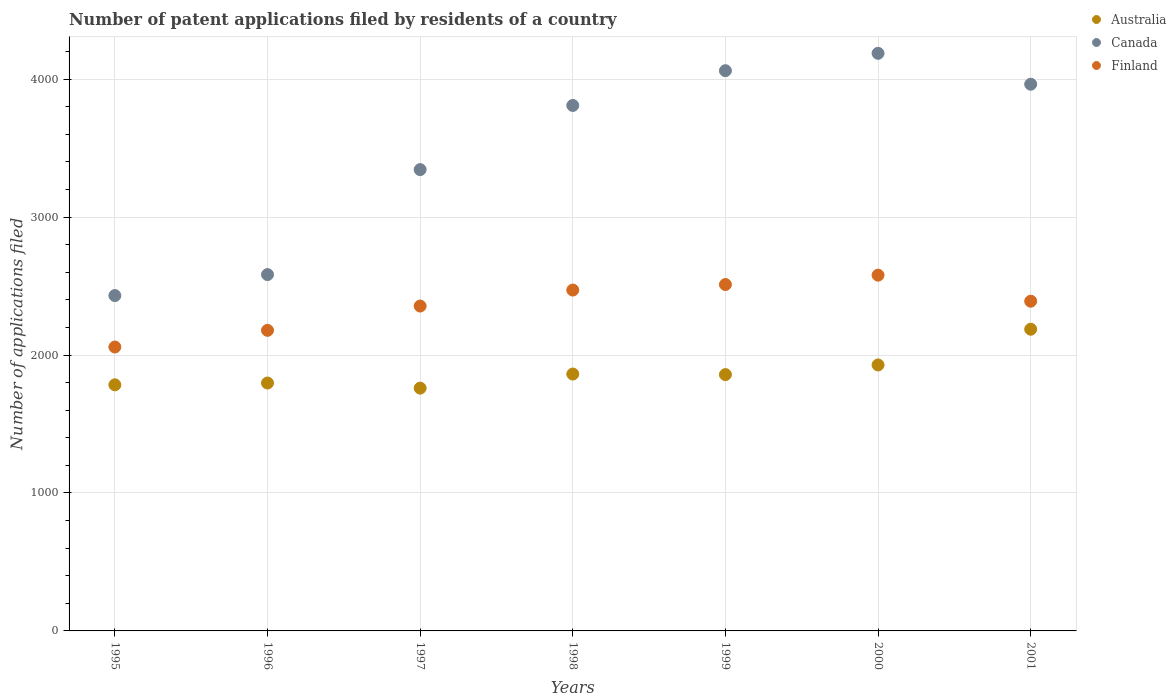How many different coloured dotlines are there?
Provide a succinct answer. 3. What is the number of applications filed in Canada in 1999?
Provide a short and direct response. 4061. Across all years, what is the maximum number of applications filed in Finland?
Provide a short and direct response. 2579. Across all years, what is the minimum number of applications filed in Finland?
Offer a terse response. 2058. What is the total number of applications filed in Australia in the graph?
Your answer should be compact. 1.32e+04. What is the difference between the number of applications filed in Australia in 1996 and that in 1998?
Your answer should be compact. -65. What is the difference between the number of applications filed in Canada in 1998 and the number of applications filed in Finland in 2001?
Offer a very short reply. 1419. What is the average number of applications filed in Canada per year?
Keep it short and to the point. 3482.57. In the year 1996, what is the difference between the number of applications filed in Canada and number of applications filed in Australia?
Your answer should be compact. 786. In how many years, is the number of applications filed in Australia greater than 600?
Provide a short and direct response. 7. What is the ratio of the number of applications filed in Canada in 1998 to that in 2001?
Give a very brief answer. 0.96. Is the number of applications filed in Australia in 1997 less than that in 1999?
Offer a very short reply. Yes. What is the difference between the highest and the second highest number of applications filed in Canada?
Your answer should be very brief. 126. What is the difference between the highest and the lowest number of applications filed in Canada?
Provide a succinct answer. 1756. Is the sum of the number of applications filed in Finland in 1995 and 1999 greater than the maximum number of applications filed in Canada across all years?
Your answer should be compact. Yes. Is it the case that in every year, the sum of the number of applications filed in Finland and number of applications filed in Canada  is greater than the number of applications filed in Australia?
Your answer should be very brief. Yes. Is the number of applications filed in Australia strictly greater than the number of applications filed in Finland over the years?
Your response must be concise. No. Is the number of applications filed in Canada strictly less than the number of applications filed in Finland over the years?
Provide a succinct answer. No. How many dotlines are there?
Ensure brevity in your answer.  3. What is the difference between two consecutive major ticks on the Y-axis?
Provide a succinct answer. 1000. Does the graph contain any zero values?
Give a very brief answer. No. Does the graph contain grids?
Offer a terse response. Yes. How many legend labels are there?
Provide a succinct answer. 3. How are the legend labels stacked?
Your answer should be compact. Vertical. What is the title of the graph?
Give a very brief answer. Number of patent applications filed by residents of a country. What is the label or title of the X-axis?
Make the answer very short. Years. What is the label or title of the Y-axis?
Offer a terse response. Number of applications filed. What is the Number of applications filed of Australia in 1995?
Your answer should be very brief. 1784. What is the Number of applications filed of Canada in 1995?
Give a very brief answer. 2431. What is the Number of applications filed of Finland in 1995?
Your response must be concise. 2058. What is the Number of applications filed in Australia in 1996?
Keep it short and to the point. 1797. What is the Number of applications filed of Canada in 1996?
Your answer should be compact. 2583. What is the Number of applications filed of Finland in 1996?
Keep it short and to the point. 2179. What is the Number of applications filed of Australia in 1997?
Keep it short and to the point. 1760. What is the Number of applications filed in Canada in 1997?
Provide a short and direct response. 3344. What is the Number of applications filed of Finland in 1997?
Ensure brevity in your answer.  2355. What is the Number of applications filed in Australia in 1998?
Provide a succinct answer. 1862. What is the Number of applications filed of Canada in 1998?
Provide a short and direct response. 3809. What is the Number of applications filed in Finland in 1998?
Ensure brevity in your answer.  2471. What is the Number of applications filed in Australia in 1999?
Your answer should be very brief. 1858. What is the Number of applications filed of Canada in 1999?
Offer a terse response. 4061. What is the Number of applications filed of Finland in 1999?
Offer a very short reply. 2511. What is the Number of applications filed of Australia in 2000?
Provide a short and direct response. 1928. What is the Number of applications filed of Canada in 2000?
Offer a very short reply. 4187. What is the Number of applications filed of Finland in 2000?
Your answer should be very brief. 2579. What is the Number of applications filed of Australia in 2001?
Provide a succinct answer. 2187. What is the Number of applications filed of Canada in 2001?
Offer a terse response. 3963. What is the Number of applications filed of Finland in 2001?
Make the answer very short. 2390. Across all years, what is the maximum Number of applications filed of Australia?
Your answer should be very brief. 2187. Across all years, what is the maximum Number of applications filed of Canada?
Your answer should be compact. 4187. Across all years, what is the maximum Number of applications filed in Finland?
Your answer should be compact. 2579. Across all years, what is the minimum Number of applications filed of Australia?
Your response must be concise. 1760. Across all years, what is the minimum Number of applications filed in Canada?
Make the answer very short. 2431. Across all years, what is the minimum Number of applications filed of Finland?
Give a very brief answer. 2058. What is the total Number of applications filed in Australia in the graph?
Your response must be concise. 1.32e+04. What is the total Number of applications filed of Canada in the graph?
Keep it short and to the point. 2.44e+04. What is the total Number of applications filed in Finland in the graph?
Provide a short and direct response. 1.65e+04. What is the difference between the Number of applications filed in Canada in 1995 and that in 1996?
Provide a succinct answer. -152. What is the difference between the Number of applications filed of Finland in 1995 and that in 1996?
Your answer should be very brief. -121. What is the difference between the Number of applications filed in Australia in 1995 and that in 1997?
Ensure brevity in your answer.  24. What is the difference between the Number of applications filed in Canada in 1995 and that in 1997?
Provide a succinct answer. -913. What is the difference between the Number of applications filed in Finland in 1995 and that in 1997?
Your answer should be compact. -297. What is the difference between the Number of applications filed in Australia in 1995 and that in 1998?
Your response must be concise. -78. What is the difference between the Number of applications filed of Canada in 1995 and that in 1998?
Provide a succinct answer. -1378. What is the difference between the Number of applications filed in Finland in 1995 and that in 1998?
Offer a very short reply. -413. What is the difference between the Number of applications filed of Australia in 1995 and that in 1999?
Provide a short and direct response. -74. What is the difference between the Number of applications filed in Canada in 1995 and that in 1999?
Provide a succinct answer. -1630. What is the difference between the Number of applications filed of Finland in 1995 and that in 1999?
Your answer should be very brief. -453. What is the difference between the Number of applications filed of Australia in 1995 and that in 2000?
Give a very brief answer. -144. What is the difference between the Number of applications filed in Canada in 1995 and that in 2000?
Provide a short and direct response. -1756. What is the difference between the Number of applications filed in Finland in 1995 and that in 2000?
Give a very brief answer. -521. What is the difference between the Number of applications filed in Australia in 1995 and that in 2001?
Make the answer very short. -403. What is the difference between the Number of applications filed of Canada in 1995 and that in 2001?
Give a very brief answer. -1532. What is the difference between the Number of applications filed in Finland in 1995 and that in 2001?
Make the answer very short. -332. What is the difference between the Number of applications filed of Australia in 1996 and that in 1997?
Offer a very short reply. 37. What is the difference between the Number of applications filed of Canada in 1996 and that in 1997?
Offer a terse response. -761. What is the difference between the Number of applications filed of Finland in 1996 and that in 1997?
Your response must be concise. -176. What is the difference between the Number of applications filed of Australia in 1996 and that in 1998?
Offer a very short reply. -65. What is the difference between the Number of applications filed in Canada in 1996 and that in 1998?
Offer a terse response. -1226. What is the difference between the Number of applications filed of Finland in 1996 and that in 1998?
Your answer should be compact. -292. What is the difference between the Number of applications filed of Australia in 1996 and that in 1999?
Offer a terse response. -61. What is the difference between the Number of applications filed in Canada in 1996 and that in 1999?
Your answer should be compact. -1478. What is the difference between the Number of applications filed of Finland in 1996 and that in 1999?
Offer a very short reply. -332. What is the difference between the Number of applications filed in Australia in 1996 and that in 2000?
Offer a terse response. -131. What is the difference between the Number of applications filed of Canada in 1996 and that in 2000?
Provide a succinct answer. -1604. What is the difference between the Number of applications filed of Finland in 1996 and that in 2000?
Provide a short and direct response. -400. What is the difference between the Number of applications filed in Australia in 1996 and that in 2001?
Provide a short and direct response. -390. What is the difference between the Number of applications filed in Canada in 1996 and that in 2001?
Make the answer very short. -1380. What is the difference between the Number of applications filed in Finland in 1996 and that in 2001?
Make the answer very short. -211. What is the difference between the Number of applications filed in Australia in 1997 and that in 1998?
Provide a succinct answer. -102. What is the difference between the Number of applications filed in Canada in 1997 and that in 1998?
Give a very brief answer. -465. What is the difference between the Number of applications filed of Finland in 1997 and that in 1998?
Your answer should be very brief. -116. What is the difference between the Number of applications filed of Australia in 1997 and that in 1999?
Offer a terse response. -98. What is the difference between the Number of applications filed in Canada in 1997 and that in 1999?
Your answer should be very brief. -717. What is the difference between the Number of applications filed of Finland in 1997 and that in 1999?
Your answer should be very brief. -156. What is the difference between the Number of applications filed in Australia in 1997 and that in 2000?
Offer a terse response. -168. What is the difference between the Number of applications filed in Canada in 1997 and that in 2000?
Provide a succinct answer. -843. What is the difference between the Number of applications filed in Finland in 1997 and that in 2000?
Make the answer very short. -224. What is the difference between the Number of applications filed in Australia in 1997 and that in 2001?
Your answer should be compact. -427. What is the difference between the Number of applications filed of Canada in 1997 and that in 2001?
Your response must be concise. -619. What is the difference between the Number of applications filed of Finland in 1997 and that in 2001?
Your answer should be very brief. -35. What is the difference between the Number of applications filed of Canada in 1998 and that in 1999?
Keep it short and to the point. -252. What is the difference between the Number of applications filed of Australia in 1998 and that in 2000?
Provide a succinct answer. -66. What is the difference between the Number of applications filed of Canada in 1998 and that in 2000?
Provide a short and direct response. -378. What is the difference between the Number of applications filed in Finland in 1998 and that in 2000?
Give a very brief answer. -108. What is the difference between the Number of applications filed in Australia in 1998 and that in 2001?
Give a very brief answer. -325. What is the difference between the Number of applications filed in Canada in 1998 and that in 2001?
Your answer should be compact. -154. What is the difference between the Number of applications filed in Australia in 1999 and that in 2000?
Give a very brief answer. -70. What is the difference between the Number of applications filed in Canada in 1999 and that in 2000?
Your response must be concise. -126. What is the difference between the Number of applications filed of Finland in 1999 and that in 2000?
Ensure brevity in your answer.  -68. What is the difference between the Number of applications filed of Australia in 1999 and that in 2001?
Offer a very short reply. -329. What is the difference between the Number of applications filed in Canada in 1999 and that in 2001?
Your answer should be very brief. 98. What is the difference between the Number of applications filed of Finland in 1999 and that in 2001?
Offer a very short reply. 121. What is the difference between the Number of applications filed in Australia in 2000 and that in 2001?
Offer a terse response. -259. What is the difference between the Number of applications filed in Canada in 2000 and that in 2001?
Keep it short and to the point. 224. What is the difference between the Number of applications filed in Finland in 2000 and that in 2001?
Ensure brevity in your answer.  189. What is the difference between the Number of applications filed of Australia in 1995 and the Number of applications filed of Canada in 1996?
Ensure brevity in your answer.  -799. What is the difference between the Number of applications filed in Australia in 1995 and the Number of applications filed in Finland in 1996?
Provide a succinct answer. -395. What is the difference between the Number of applications filed in Canada in 1995 and the Number of applications filed in Finland in 1996?
Provide a short and direct response. 252. What is the difference between the Number of applications filed of Australia in 1995 and the Number of applications filed of Canada in 1997?
Provide a succinct answer. -1560. What is the difference between the Number of applications filed of Australia in 1995 and the Number of applications filed of Finland in 1997?
Provide a succinct answer. -571. What is the difference between the Number of applications filed in Australia in 1995 and the Number of applications filed in Canada in 1998?
Provide a short and direct response. -2025. What is the difference between the Number of applications filed of Australia in 1995 and the Number of applications filed of Finland in 1998?
Your answer should be very brief. -687. What is the difference between the Number of applications filed of Canada in 1995 and the Number of applications filed of Finland in 1998?
Your response must be concise. -40. What is the difference between the Number of applications filed of Australia in 1995 and the Number of applications filed of Canada in 1999?
Your response must be concise. -2277. What is the difference between the Number of applications filed in Australia in 1995 and the Number of applications filed in Finland in 1999?
Make the answer very short. -727. What is the difference between the Number of applications filed in Canada in 1995 and the Number of applications filed in Finland in 1999?
Your response must be concise. -80. What is the difference between the Number of applications filed in Australia in 1995 and the Number of applications filed in Canada in 2000?
Give a very brief answer. -2403. What is the difference between the Number of applications filed in Australia in 1995 and the Number of applications filed in Finland in 2000?
Your response must be concise. -795. What is the difference between the Number of applications filed of Canada in 1995 and the Number of applications filed of Finland in 2000?
Offer a very short reply. -148. What is the difference between the Number of applications filed of Australia in 1995 and the Number of applications filed of Canada in 2001?
Ensure brevity in your answer.  -2179. What is the difference between the Number of applications filed of Australia in 1995 and the Number of applications filed of Finland in 2001?
Provide a short and direct response. -606. What is the difference between the Number of applications filed in Canada in 1995 and the Number of applications filed in Finland in 2001?
Provide a succinct answer. 41. What is the difference between the Number of applications filed of Australia in 1996 and the Number of applications filed of Canada in 1997?
Offer a terse response. -1547. What is the difference between the Number of applications filed in Australia in 1996 and the Number of applications filed in Finland in 1997?
Provide a succinct answer. -558. What is the difference between the Number of applications filed of Canada in 1996 and the Number of applications filed of Finland in 1997?
Your response must be concise. 228. What is the difference between the Number of applications filed in Australia in 1996 and the Number of applications filed in Canada in 1998?
Give a very brief answer. -2012. What is the difference between the Number of applications filed of Australia in 1996 and the Number of applications filed of Finland in 1998?
Your answer should be compact. -674. What is the difference between the Number of applications filed in Canada in 1996 and the Number of applications filed in Finland in 1998?
Offer a terse response. 112. What is the difference between the Number of applications filed of Australia in 1996 and the Number of applications filed of Canada in 1999?
Ensure brevity in your answer.  -2264. What is the difference between the Number of applications filed in Australia in 1996 and the Number of applications filed in Finland in 1999?
Give a very brief answer. -714. What is the difference between the Number of applications filed in Australia in 1996 and the Number of applications filed in Canada in 2000?
Your answer should be compact. -2390. What is the difference between the Number of applications filed in Australia in 1996 and the Number of applications filed in Finland in 2000?
Make the answer very short. -782. What is the difference between the Number of applications filed of Canada in 1996 and the Number of applications filed of Finland in 2000?
Your answer should be compact. 4. What is the difference between the Number of applications filed in Australia in 1996 and the Number of applications filed in Canada in 2001?
Give a very brief answer. -2166. What is the difference between the Number of applications filed of Australia in 1996 and the Number of applications filed of Finland in 2001?
Offer a terse response. -593. What is the difference between the Number of applications filed of Canada in 1996 and the Number of applications filed of Finland in 2001?
Keep it short and to the point. 193. What is the difference between the Number of applications filed of Australia in 1997 and the Number of applications filed of Canada in 1998?
Offer a terse response. -2049. What is the difference between the Number of applications filed in Australia in 1997 and the Number of applications filed in Finland in 1998?
Your answer should be very brief. -711. What is the difference between the Number of applications filed in Canada in 1997 and the Number of applications filed in Finland in 1998?
Ensure brevity in your answer.  873. What is the difference between the Number of applications filed of Australia in 1997 and the Number of applications filed of Canada in 1999?
Your answer should be compact. -2301. What is the difference between the Number of applications filed in Australia in 1997 and the Number of applications filed in Finland in 1999?
Give a very brief answer. -751. What is the difference between the Number of applications filed of Canada in 1997 and the Number of applications filed of Finland in 1999?
Keep it short and to the point. 833. What is the difference between the Number of applications filed in Australia in 1997 and the Number of applications filed in Canada in 2000?
Your response must be concise. -2427. What is the difference between the Number of applications filed of Australia in 1997 and the Number of applications filed of Finland in 2000?
Provide a short and direct response. -819. What is the difference between the Number of applications filed of Canada in 1997 and the Number of applications filed of Finland in 2000?
Your answer should be compact. 765. What is the difference between the Number of applications filed of Australia in 1997 and the Number of applications filed of Canada in 2001?
Give a very brief answer. -2203. What is the difference between the Number of applications filed in Australia in 1997 and the Number of applications filed in Finland in 2001?
Provide a succinct answer. -630. What is the difference between the Number of applications filed in Canada in 1997 and the Number of applications filed in Finland in 2001?
Offer a terse response. 954. What is the difference between the Number of applications filed of Australia in 1998 and the Number of applications filed of Canada in 1999?
Ensure brevity in your answer.  -2199. What is the difference between the Number of applications filed of Australia in 1998 and the Number of applications filed of Finland in 1999?
Your answer should be very brief. -649. What is the difference between the Number of applications filed in Canada in 1998 and the Number of applications filed in Finland in 1999?
Provide a succinct answer. 1298. What is the difference between the Number of applications filed in Australia in 1998 and the Number of applications filed in Canada in 2000?
Your answer should be very brief. -2325. What is the difference between the Number of applications filed in Australia in 1998 and the Number of applications filed in Finland in 2000?
Offer a very short reply. -717. What is the difference between the Number of applications filed of Canada in 1998 and the Number of applications filed of Finland in 2000?
Provide a succinct answer. 1230. What is the difference between the Number of applications filed in Australia in 1998 and the Number of applications filed in Canada in 2001?
Provide a succinct answer. -2101. What is the difference between the Number of applications filed in Australia in 1998 and the Number of applications filed in Finland in 2001?
Ensure brevity in your answer.  -528. What is the difference between the Number of applications filed in Canada in 1998 and the Number of applications filed in Finland in 2001?
Your response must be concise. 1419. What is the difference between the Number of applications filed in Australia in 1999 and the Number of applications filed in Canada in 2000?
Provide a succinct answer. -2329. What is the difference between the Number of applications filed in Australia in 1999 and the Number of applications filed in Finland in 2000?
Your answer should be very brief. -721. What is the difference between the Number of applications filed in Canada in 1999 and the Number of applications filed in Finland in 2000?
Make the answer very short. 1482. What is the difference between the Number of applications filed of Australia in 1999 and the Number of applications filed of Canada in 2001?
Your answer should be compact. -2105. What is the difference between the Number of applications filed in Australia in 1999 and the Number of applications filed in Finland in 2001?
Your answer should be compact. -532. What is the difference between the Number of applications filed in Canada in 1999 and the Number of applications filed in Finland in 2001?
Give a very brief answer. 1671. What is the difference between the Number of applications filed in Australia in 2000 and the Number of applications filed in Canada in 2001?
Give a very brief answer. -2035. What is the difference between the Number of applications filed in Australia in 2000 and the Number of applications filed in Finland in 2001?
Your response must be concise. -462. What is the difference between the Number of applications filed of Canada in 2000 and the Number of applications filed of Finland in 2001?
Keep it short and to the point. 1797. What is the average Number of applications filed of Australia per year?
Your response must be concise. 1882.29. What is the average Number of applications filed in Canada per year?
Offer a terse response. 3482.57. What is the average Number of applications filed of Finland per year?
Your answer should be very brief. 2363.29. In the year 1995, what is the difference between the Number of applications filed in Australia and Number of applications filed in Canada?
Your answer should be very brief. -647. In the year 1995, what is the difference between the Number of applications filed in Australia and Number of applications filed in Finland?
Give a very brief answer. -274. In the year 1995, what is the difference between the Number of applications filed in Canada and Number of applications filed in Finland?
Keep it short and to the point. 373. In the year 1996, what is the difference between the Number of applications filed in Australia and Number of applications filed in Canada?
Your response must be concise. -786. In the year 1996, what is the difference between the Number of applications filed in Australia and Number of applications filed in Finland?
Provide a short and direct response. -382. In the year 1996, what is the difference between the Number of applications filed of Canada and Number of applications filed of Finland?
Keep it short and to the point. 404. In the year 1997, what is the difference between the Number of applications filed in Australia and Number of applications filed in Canada?
Make the answer very short. -1584. In the year 1997, what is the difference between the Number of applications filed in Australia and Number of applications filed in Finland?
Ensure brevity in your answer.  -595. In the year 1997, what is the difference between the Number of applications filed of Canada and Number of applications filed of Finland?
Offer a terse response. 989. In the year 1998, what is the difference between the Number of applications filed of Australia and Number of applications filed of Canada?
Give a very brief answer. -1947. In the year 1998, what is the difference between the Number of applications filed of Australia and Number of applications filed of Finland?
Make the answer very short. -609. In the year 1998, what is the difference between the Number of applications filed of Canada and Number of applications filed of Finland?
Make the answer very short. 1338. In the year 1999, what is the difference between the Number of applications filed in Australia and Number of applications filed in Canada?
Your answer should be compact. -2203. In the year 1999, what is the difference between the Number of applications filed in Australia and Number of applications filed in Finland?
Give a very brief answer. -653. In the year 1999, what is the difference between the Number of applications filed of Canada and Number of applications filed of Finland?
Keep it short and to the point. 1550. In the year 2000, what is the difference between the Number of applications filed in Australia and Number of applications filed in Canada?
Your answer should be compact. -2259. In the year 2000, what is the difference between the Number of applications filed of Australia and Number of applications filed of Finland?
Offer a terse response. -651. In the year 2000, what is the difference between the Number of applications filed in Canada and Number of applications filed in Finland?
Your answer should be compact. 1608. In the year 2001, what is the difference between the Number of applications filed of Australia and Number of applications filed of Canada?
Provide a short and direct response. -1776. In the year 2001, what is the difference between the Number of applications filed in Australia and Number of applications filed in Finland?
Keep it short and to the point. -203. In the year 2001, what is the difference between the Number of applications filed of Canada and Number of applications filed of Finland?
Give a very brief answer. 1573. What is the ratio of the Number of applications filed in Canada in 1995 to that in 1996?
Your answer should be very brief. 0.94. What is the ratio of the Number of applications filed of Finland in 1995 to that in 1996?
Your response must be concise. 0.94. What is the ratio of the Number of applications filed in Australia in 1995 to that in 1997?
Make the answer very short. 1.01. What is the ratio of the Number of applications filed in Canada in 1995 to that in 1997?
Your answer should be compact. 0.73. What is the ratio of the Number of applications filed of Finland in 1995 to that in 1997?
Offer a very short reply. 0.87. What is the ratio of the Number of applications filed in Australia in 1995 to that in 1998?
Provide a short and direct response. 0.96. What is the ratio of the Number of applications filed of Canada in 1995 to that in 1998?
Your answer should be very brief. 0.64. What is the ratio of the Number of applications filed in Finland in 1995 to that in 1998?
Your answer should be compact. 0.83. What is the ratio of the Number of applications filed of Australia in 1995 to that in 1999?
Provide a succinct answer. 0.96. What is the ratio of the Number of applications filed in Canada in 1995 to that in 1999?
Provide a short and direct response. 0.6. What is the ratio of the Number of applications filed of Finland in 1995 to that in 1999?
Keep it short and to the point. 0.82. What is the ratio of the Number of applications filed in Australia in 1995 to that in 2000?
Offer a terse response. 0.93. What is the ratio of the Number of applications filed in Canada in 1995 to that in 2000?
Ensure brevity in your answer.  0.58. What is the ratio of the Number of applications filed in Finland in 1995 to that in 2000?
Ensure brevity in your answer.  0.8. What is the ratio of the Number of applications filed of Australia in 1995 to that in 2001?
Provide a succinct answer. 0.82. What is the ratio of the Number of applications filed in Canada in 1995 to that in 2001?
Offer a terse response. 0.61. What is the ratio of the Number of applications filed in Finland in 1995 to that in 2001?
Your answer should be very brief. 0.86. What is the ratio of the Number of applications filed of Australia in 1996 to that in 1997?
Your response must be concise. 1.02. What is the ratio of the Number of applications filed of Canada in 1996 to that in 1997?
Keep it short and to the point. 0.77. What is the ratio of the Number of applications filed of Finland in 1996 to that in 1997?
Provide a short and direct response. 0.93. What is the ratio of the Number of applications filed of Australia in 1996 to that in 1998?
Make the answer very short. 0.97. What is the ratio of the Number of applications filed of Canada in 1996 to that in 1998?
Keep it short and to the point. 0.68. What is the ratio of the Number of applications filed in Finland in 1996 to that in 1998?
Give a very brief answer. 0.88. What is the ratio of the Number of applications filed of Australia in 1996 to that in 1999?
Offer a very short reply. 0.97. What is the ratio of the Number of applications filed of Canada in 1996 to that in 1999?
Offer a very short reply. 0.64. What is the ratio of the Number of applications filed in Finland in 1996 to that in 1999?
Give a very brief answer. 0.87. What is the ratio of the Number of applications filed of Australia in 1996 to that in 2000?
Your answer should be very brief. 0.93. What is the ratio of the Number of applications filed of Canada in 1996 to that in 2000?
Offer a very short reply. 0.62. What is the ratio of the Number of applications filed in Finland in 1996 to that in 2000?
Make the answer very short. 0.84. What is the ratio of the Number of applications filed in Australia in 1996 to that in 2001?
Keep it short and to the point. 0.82. What is the ratio of the Number of applications filed of Canada in 1996 to that in 2001?
Ensure brevity in your answer.  0.65. What is the ratio of the Number of applications filed of Finland in 1996 to that in 2001?
Offer a terse response. 0.91. What is the ratio of the Number of applications filed of Australia in 1997 to that in 1998?
Your answer should be very brief. 0.95. What is the ratio of the Number of applications filed of Canada in 1997 to that in 1998?
Provide a succinct answer. 0.88. What is the ratio of the Number of applications filed in Finland in 1997 to that in 1998?
Provide a short and direct response. 0.95. What is the ratio of the Number of applications filed in Australia in 1997 to that in 1999?
Your response must be concise. 0.95. What is the ratio of the Number of applications filed in Canada in 1997 to that in 1999?
Provide a short and direct response. 0.82. What is the ratio of the Number of applications filed of Finland in 1997 to that in 1999?
Your answer should be compact. 0.94. What is the ratio of the Number of applications filed of Australia in 1997 to that in 2000?
Ensure brevity in your answer.  0.91. What is the ratio of the Number of applications filed in Canada in 1997 to that in 2000?
Give a very brief answer. 0.8. What is the ratio of the Number of applications filed in Finland in 1997 to that in 2000?
Provide a short and direct response. 0.91. What is the ratio of the Number of applications filed of Australia in 1997 to that in 2001?
Your response must be concise. 0.8. What is the ratio of the Number of applications filed in Canada in 1997 to that in 2001?
Offer a terse response. 0.84. What is the ratio of the Number of applications filed of Finland in 1997 to that in 2001?
Your answer should be compact. 0.99. What is the ratio of the Number of applications filed of Canada in 1998 to that in 1999?
Provide a short and direct response. 0.94. What is the ratio of the Number of applications filed of Finland in 1998 to that in 1999?
Provide a succinct answer. 0.98. What is the ratio of the Number of applications filed in Australia in 1998 to that in 2000?
Provide a succinct answer. 0.97. What is the ratio of the Number of applications filed of Canada in 1998 to that in 2000?
Your answer should be compact. 0.91. What is the ratio of the Number of applications filed in Finland in 1998 to that in 2000?
Offer a very short reply. 0.96. What is the ratio of the Number of applications filed of Australia in 1998 to that in 2001?
Provide a short and direct response. 0.85. What is the ratio of the Number of applications filed in Canada in 1998 to that in 2001?
Offer a very short reply. 0.96. What is the ratio of the Number of applications filed of Finland in 1998 to that in 2001?
Offer a terse response. 1.03. What is the ratio of the Number of applications filed in Australia in 1999 to that in 2000?
Make the answer very short. 0.96. What is the ratio of the Number of applications filed of Canada in 1999 to that in 2000?
Give a very brief answer. 0.97. What is the ratio of the Number of applications filed of Finland in 1999 to that in 2000?
Ensure brevity in your answer.  0.97. What is the ratio of the Number of applications filed in Australia in 1999 to that in 2001?
Your answer should be very brief. 0.85. What is the ratio of the Number of applications filed in Canada in 1999 to that in 2001?
Keep it short and to the point. 1.02. What is the ratio of the Number of applications filed in Finland in 1999 to that in 2001?
Your response must be concise. 1.05. What is the ratio of the Number of applications filed in Australia in 2000 to that in 2001?
Give a very brief answer. 0.88. What is the ratio of the Number of applications filed in Canada in 2000 to that in 2001?
Make the answer very short. 1.06. What is the ratio of the Number of applications filed of Finland in 2000 to that in 2001?
Offer a very short reply. 1.08. What is the difference between the highest and the second highest Number of applications filed in Australia?
Offer a very short reply. 259. What is the difference between the highest and the second highest Number of applications filed in Canada?
Provide a succinct answer. 126. What is the difference between the highest and the second highest Number of applications filed of Finland?
Your response must be concise. 68. What is the difference between the highest and the lowest Number of applications filed in Australia?
Your answer should be very brief. 427. What is the difference between the highest and the lowest Number of applications filed of Canada?
Your response must be concise. 1756. What is the difference between the highest and the lowest Number of applications filed in Finland?
Your answer should be compact. 521. 